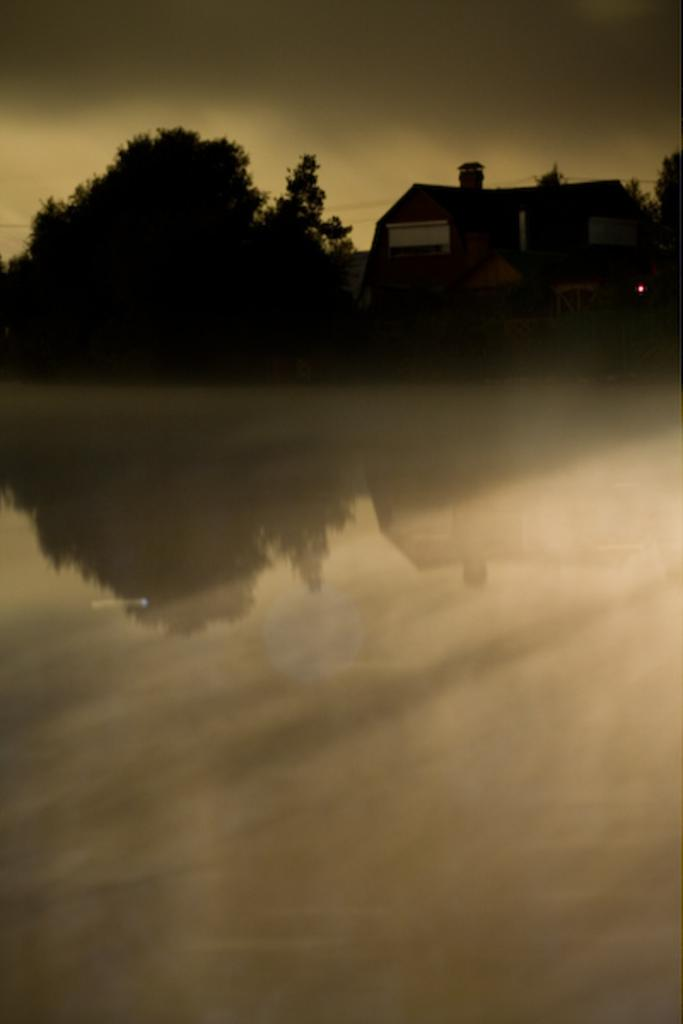What type of vegetation can be seen in the image? There are trees in the image. What type of structure is visible in the image? There is a house in the image. Where are the house and trees located in the image? The house and trees are located at the top side of the image. What color is the baby's stocking in the image? There is no baby or stocking present in the image. How many hours of sleep can be seen in the image? There is no indication of sleep or a sleeping person in the image. 